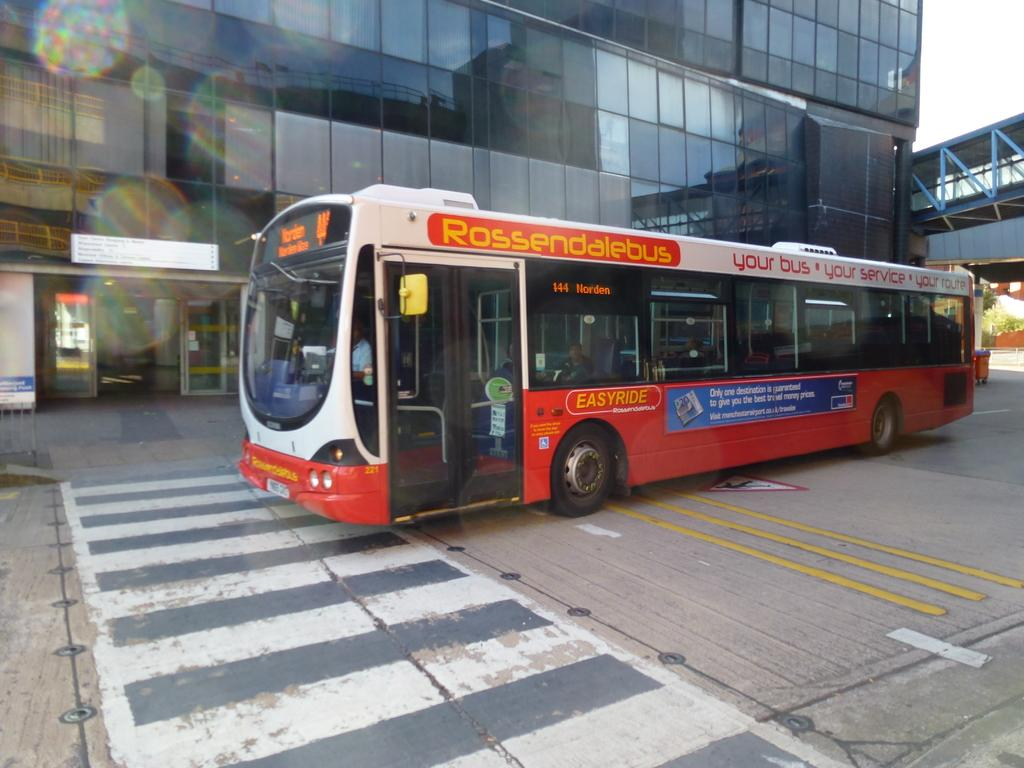<image>
Offer a succinct explanation of the picture presented. Roseendalebus offers an easy ride to those who use its services. 